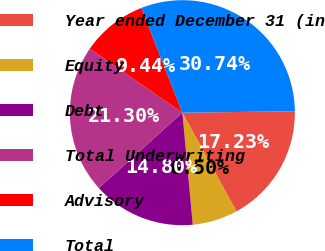Convert chart to OTSL. <chart><loc_0><loc_0><loc_500><loc_500><pie_chart><fcel>Year ended December 31 (in<fcel>Equity<fcel>Debt<fcel>Total Underwriting<fcel>Advisory<fcel>Total<nl><fcel>17.23%<fcel>6.5%<fcel>14.8%<fcel>21.3%<fcel>9.44%<fcel>30.74%<nl></chart> 